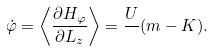Convert formula to latex. <formula><loc_0><loc_0><loc_500><loc_500>\dot { \varphi } = \left \langle \frac { \partial H _ { \varphi } } { \partial L _ { z } } \right \rangle = \frac { U } { } ( m - K ) .</formula> 